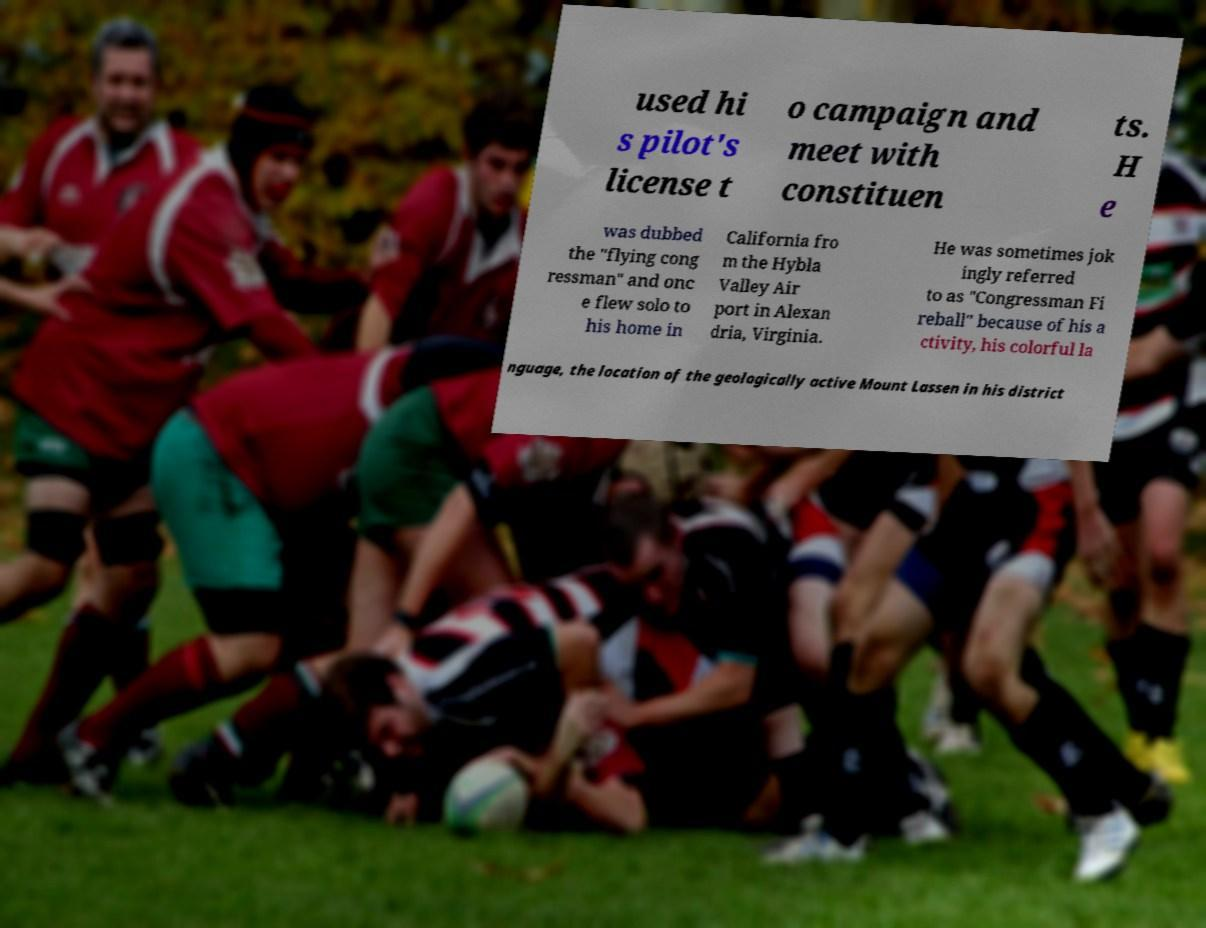There's text embedded in this image that I need extracted. Can you transcribe it verbatim? used hi s pilot's license t o campaign and meet with constituen ts. H e was dubbed the "flying cong ressman" and onc e flew solo to his home in California fro m the Hybla Valley Air port in Alexan dria, Virginia. He was sometimes jok ingly referred to as "Congressman Fi reball" because of his a ctivity, his colorful la nguage, the location of the geologically active Mount Lassen in his district 